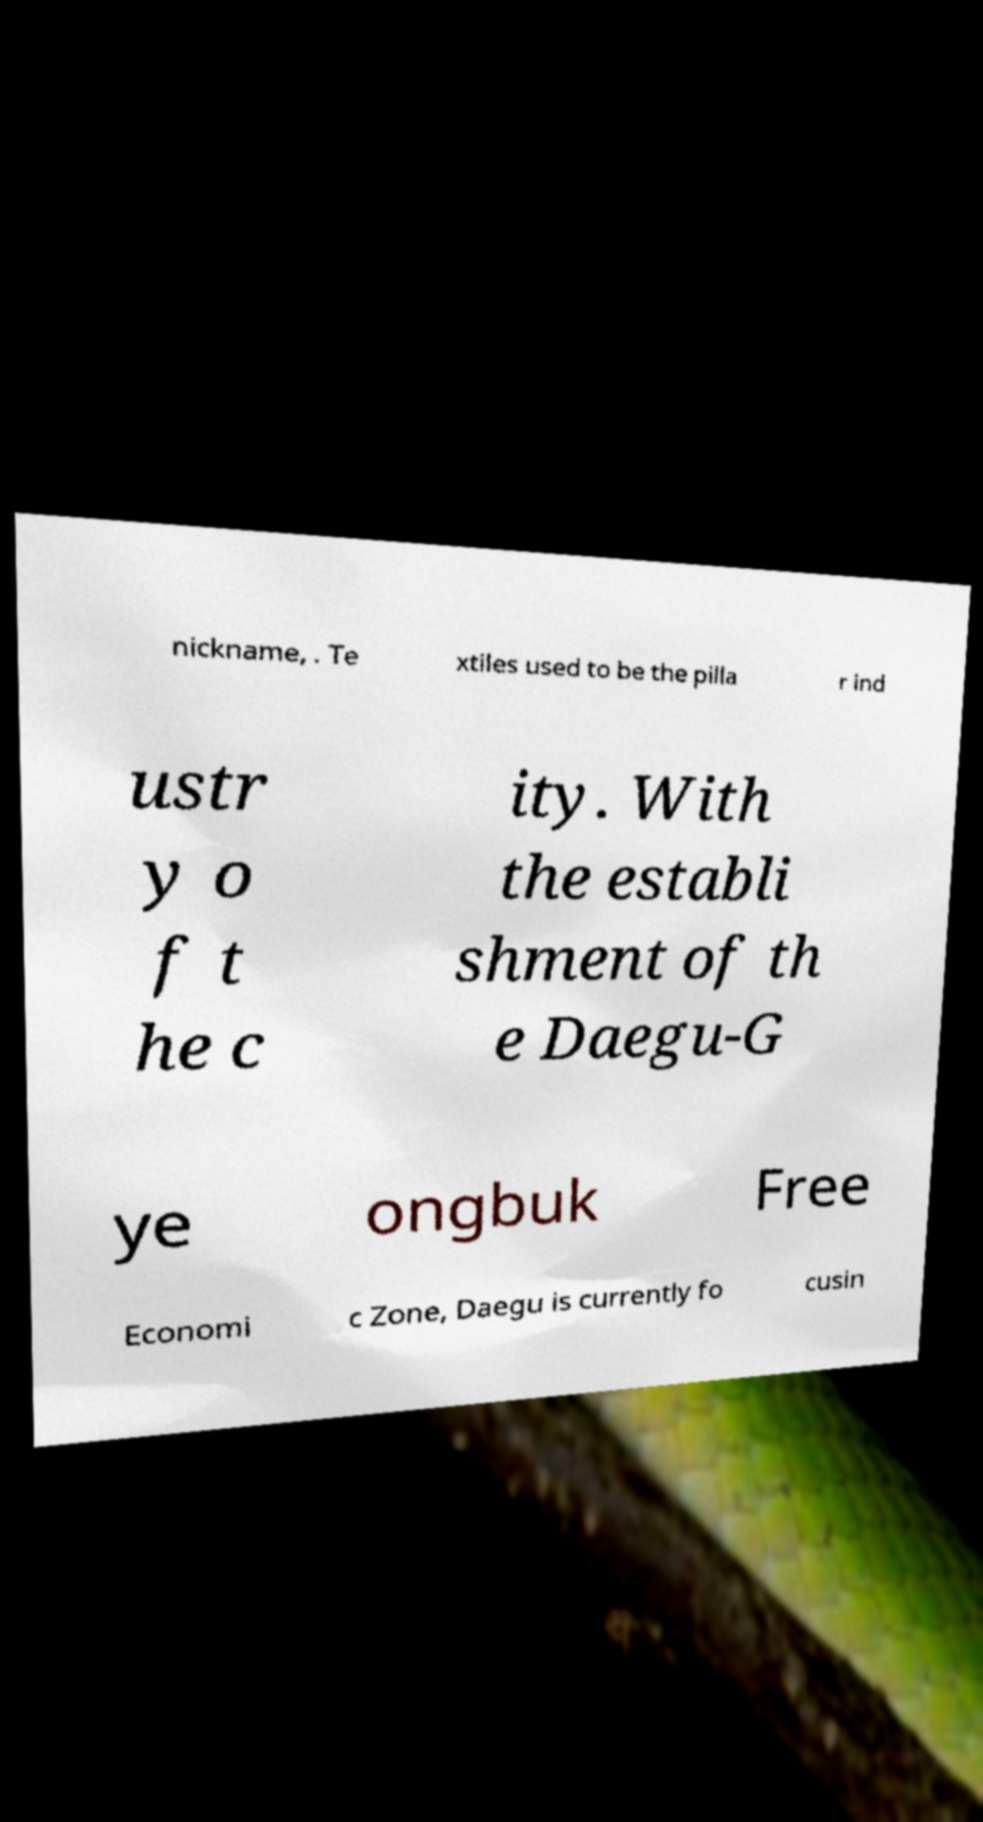For documentation purposes, I need the text within this image transcribed. Could you provide that? nickname, . Te xtiles used to be the pilla r ind ustr y o f t he c ity. With the establi shment of th e Daegu-G ye ongbuk Free Economi c Zone, Daegu is currently fo cusin 